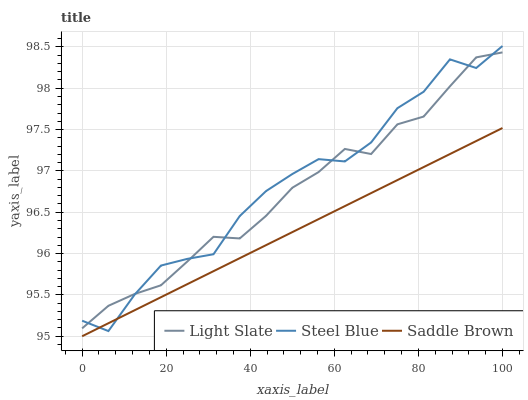Does Saddle Brown have the minimum area under the curve?
Answer yes or no. Yes. Does Steel Blue have the maximum area under the curve?
Answer yes or no. Yes. Does Steel Blue have the minimum area under the curve?
Answer yes or no. No. Does Saddle Brown have the maximum area under the curve?
Answer yes or no. No. Is Saddle Brown the smoothest?
Answer yes or no. Yes. Is Steel Blue the roughest?
Answer yes or no. Yes. Is Steel Blue the smoothest?
Answer yes or no. No. Is Saddle Brown the roughest?
Answer yes or no. No. Does Saddle Brown have the lowest value?
Answer yes or no. Yes. Does Steel Blue have the lowest value?
Answer yes or no. No. Does Steel Blue have the highest value?
Answer yes or no. Yes. Does Saddle Brown have the highest value?
Answer yes or no. No. Is Saddle Brown less than Light Slate?
Answer yes or no. Yes. Is Light Slate greater than Saddle Brown?
Answer yes or no. Yes. Does Light Slate intersect Steel Blue?
Answer yes or no. Yes. Is Light Slate less than Steel Blue?
Answer yes or no. No. Is Light Slate greater than Steel Blue?
Answer yes or no. No. Does Saddle Brown intersect Light Slate?
Answer yes or no. No. 